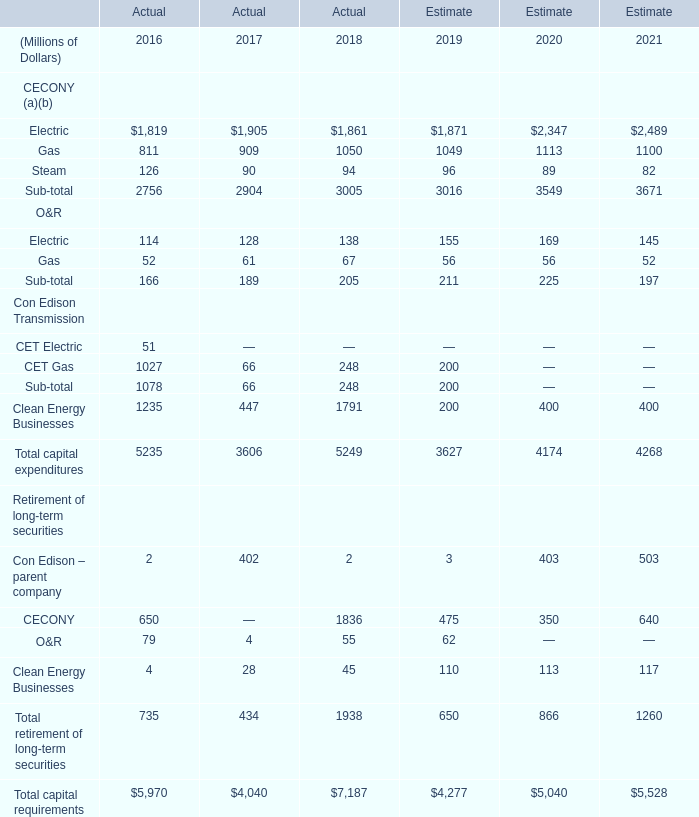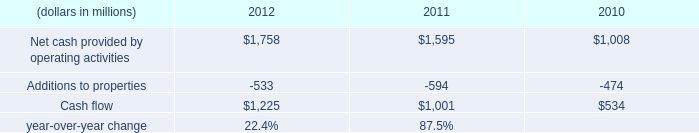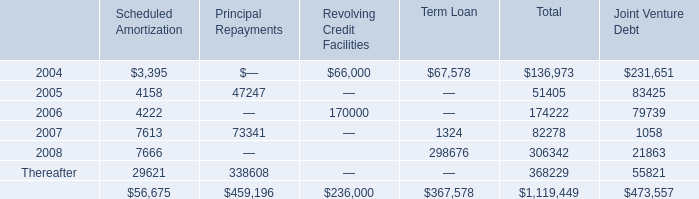What is the average amount of Electric of Estimate 2020, and Cash flow of 2012 ? 
Computations: ((2347.0 + 1225.0) / 2)
Answer: 1786.0. 